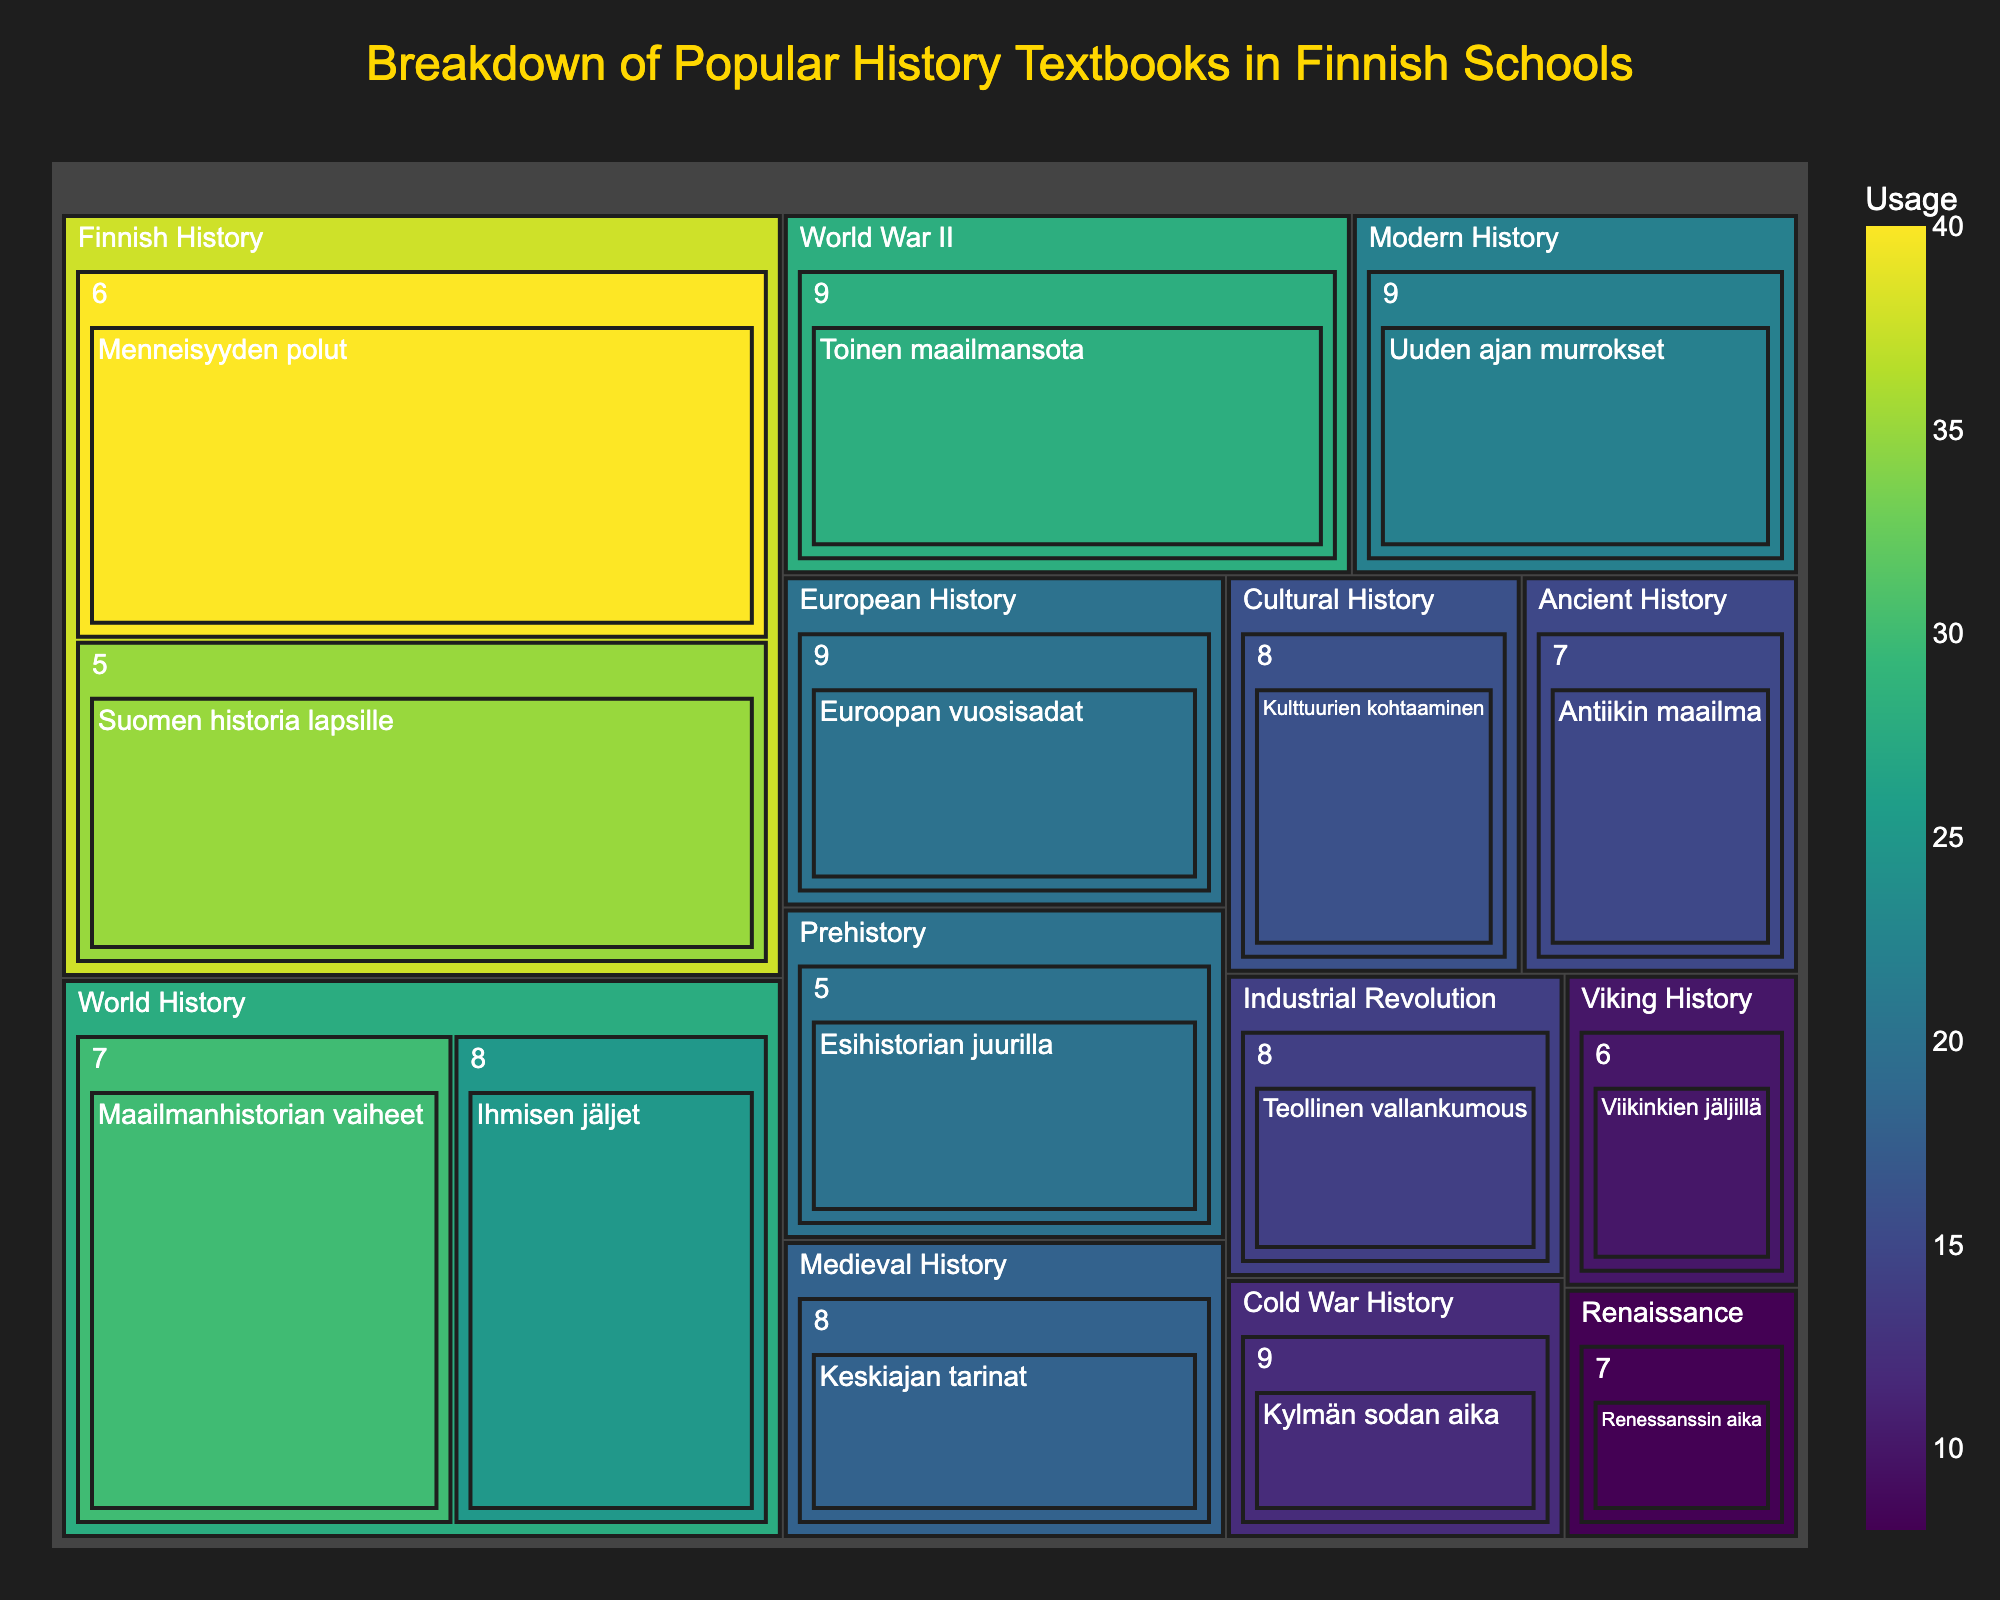How many textbooks are used for Grade 9? Look at the branches for Grade 9 in each subject category in the treemap and count the number of textbooks listed under Grade 9.
Answer: 4 Which history subject has the highest textbook usage in Grade 7? Look at the branches under Grade 7 and compare the usage values for each textbook. The highest number indicates the subject with the highest textbook usage.
Answer: World History What is the total textbook usage for Finnish History across all grades? Add the usage values for textbooks listed under the Finnish History subject: Suomen historia lapsille (35) and Menneisyyden polut (40).
Answer: 75 Which subject has the least total usage, and what is the value? Sum the usage values of textbooks within each subject category. The subject with the smallest sum is the one with the least total usage.
Answer: Renaissance, 8 How does the usage of "Suomen historia lapsille" compare to "Menneisyyden polut"? Look at the usage values for "Suomen historia lapsille" and "Menneisyyden polut" directly under the Finnish History category. Compare the values to determine which is higher.
Answer: Menneisyyden polut has higher usage What is the combined usage of Grade 8 textbooks? Add the usage values for textbooks listed under Grade 8: Ihmisen jäljet (25), Keskiajan tarinat (18), Teollinen vallankumous (14), Kulttuurien kohtaaminen (16).
Answer: 73 Which Grade 9 textbook has the lowest usage, and what is the value? Look at the branches under Grade 9 and find the textbook with the lowest usage value.
Answer: Kylmän sodan aika, 12 